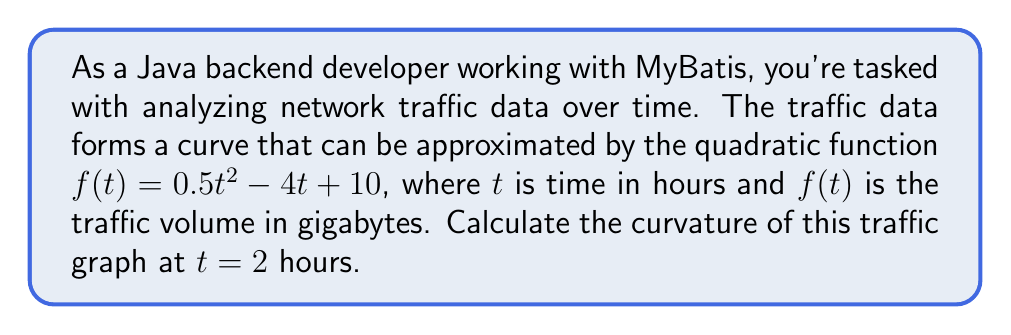Give your solution to this math problem. To calculate the curvature of a function at a specific point, we use the formula:

$$\kappa = \frac{|f''(t)|}{(1 + [f'(t)]^2)^{3/2}}$$

Where $f'(t)$ is the first derivative and $f''(t)$ is the second derivative of the function.

Step 1: Find $f'(t)$
$$f'(t) = \frac{d}{dt}(0.5t^2 - 4t + 10) = t - 4$$

Step 2: Find $f''(t)$
$$f''(t) = \frac{d}{dt}(t - 4) = 1$$

Step 3: Evaluate $f'(t)$ at $t = 2$
$$f'(2) = 2 - 4 = -2$$

Step 4: Substitute values into the curvature formula
$$\kappa = \frac{|f''(2)|}{(1 + [f'(2)]^2)^{3/2}} = \frac{|1|}{(1 + [-2]^2)^{3/2}}$$

Step 5: Simplify and calculate
$$\kappa = \frac{1}{(1 + 4)^{3/2}} = \frac{1}{5^{3/2}} = \frac{1}{5\sqrt{5}}$$

This result represents the curvature of the network traffic graph at $t = 2$ hours.
Answer: $\frac{1}{5\sqrt{5}}$ 